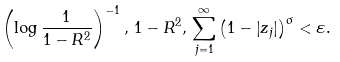<formula> <loc_0><loc_0><loc_500><loc_500>\left ( \log \frac { 1 } { 1 - R ^ { 2 } } \right ) ^ { - 1 } , \, 1 - R ^ { 2 } , \, \sum _ { j = 1 } ^ { \infty } \left ( 1 - \left | z _ { j } \right | \right ) ^ { \sigma } < \varepsilon .</formula> 